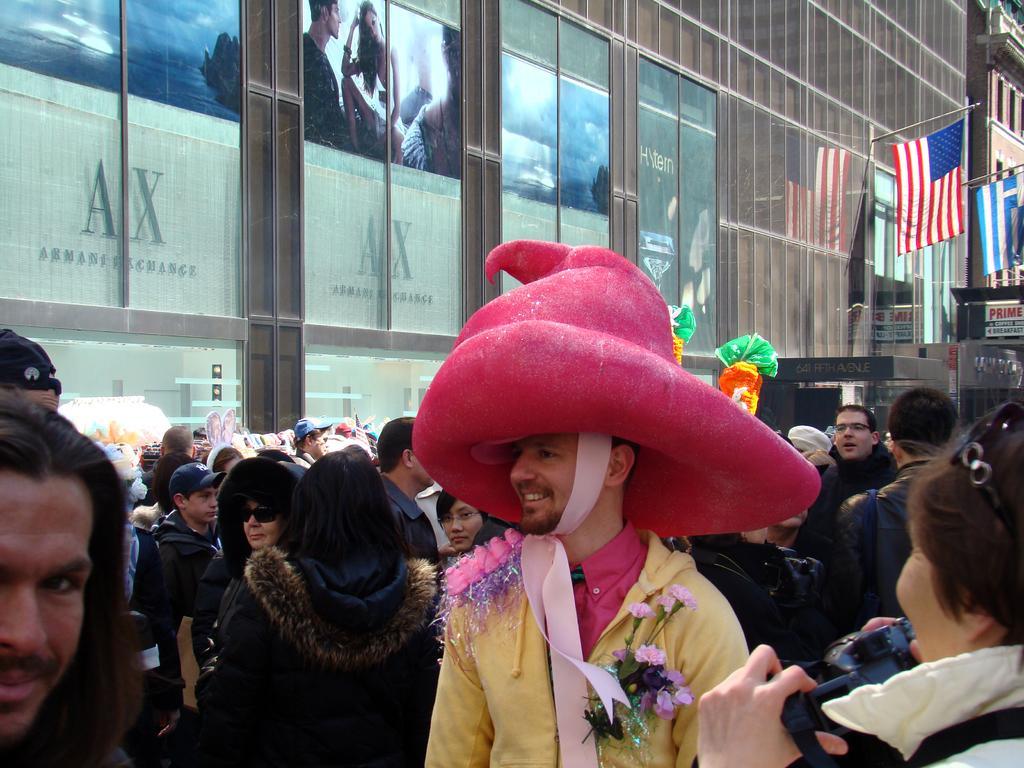How would you summarize this image in a sentence or two? In this picture we can see a man wearing a yellow dress with a pink hat, standing in the front. Behind there are some people in the crowd. In the background we can see a glass building and american flag.  